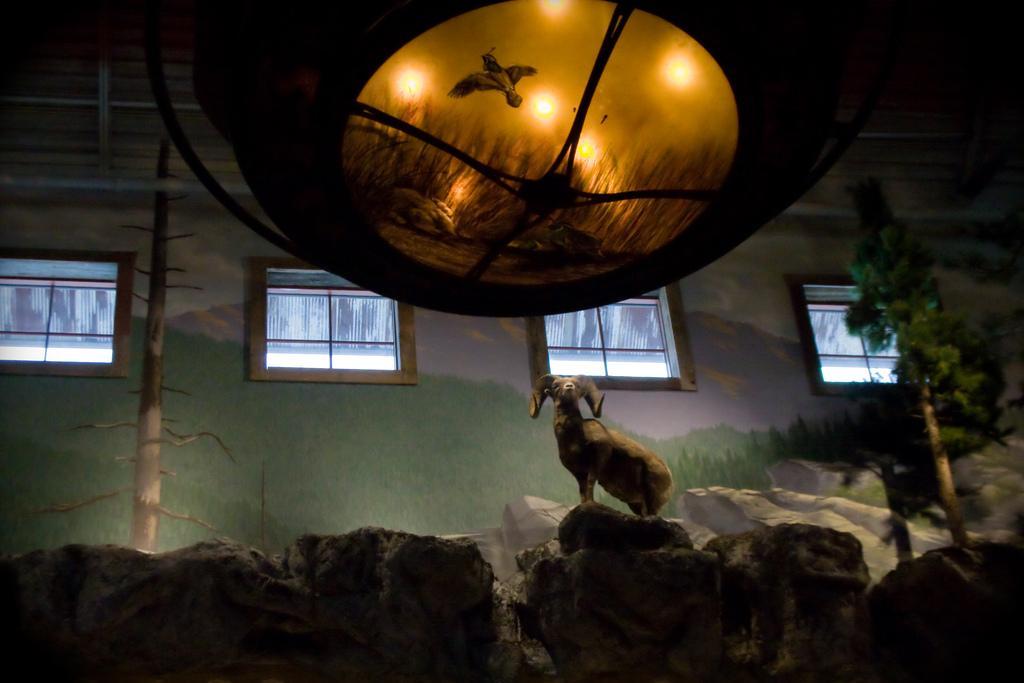In one or two sentences, can you explain what this image depicts? This image clicked inside the room. At the bottom, we can see the rocks. In the background, there is a wall along with windows. At the top, it looks like a light. In the front, we can see a sheep. At the top, there is a roof. On the right, there is a tree. All these things seems to be like artificial. 